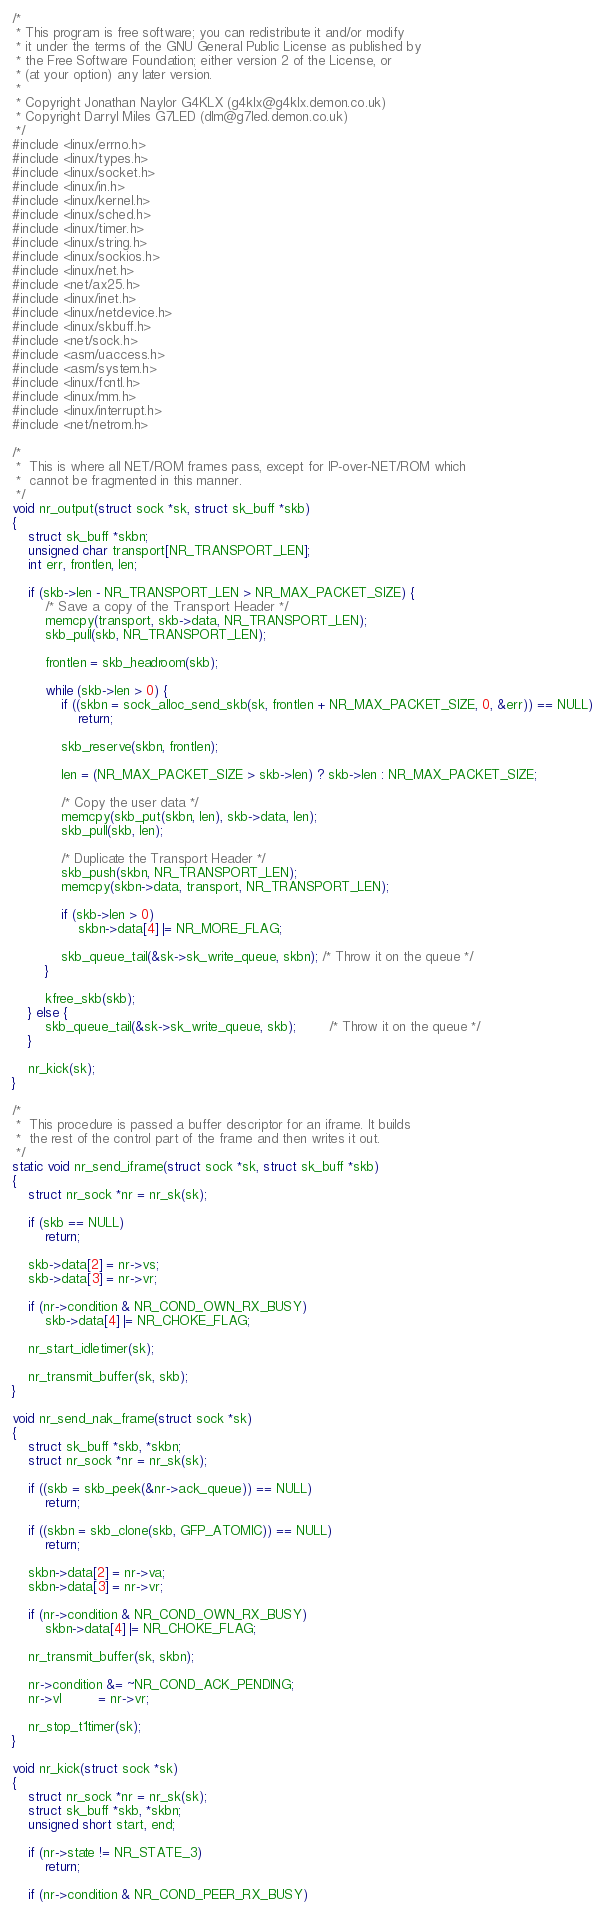Convert code to text. <code><loc_0><loc_0><loc_500><loc_500><_C_>/*
 * This program is free software; you can redistribute it and/or modify
 * it under the terms of the GNU General Public License as published by
 * the Free Software Foundation; either version 2 of the License, or
 * (at your option) any later version.
 *
 * Copyright Jonathan Naylor G4KLX (g4klx@g4klx.demon.co.uk)
 * Copyright Darryl Miles G7LED (dlm@g7led.demon.co.uk)
 */
#include <linux/errno.h>
#include <linux/types.h>
#include <linux/socket.h>
#include <linux/in.h>
#include <linux/kernel.h>
#include <linux/sched.h>
#include <linux/timer.h>
#include <linux/string.h>
#include <linux/sockios.h>
#include <linux/net.h>
#include <net/ax25.h>
#include <linux/inet.h>
#include <linux/netdevice.h>
#include <linux/skbuff.h>
#include <net/sock.h>
#include <asm/uaccess.h>
#include <asm/system.h>
#include <linux/fcntl.h>
#include <linux/mm.h>
#include <linux/interrupt.h>
#include <net/netrom.h>

/*
 *	This is where all NET/ROM frames pass, except for IP-over-NET/ROM which
 *	cannot be fragmented in this manner.
 */
void nr_output(struct sock *sk, struct sk_buff *skb)
{
	struct sk_buff *skbn;
	unsigned char transport[NR_TRANSPORT_LEN];
	int err, frontlen, len;

	if (skb->len - NR_TRANSPORT_LEN > NR_MAX_PACKET_SIZE) {
		/* Save a copy of the Transport Header */
		memcpy(transport, skb->data, NR_TRANSPORT_LEN);
		skb_pull(skb, NR_TRANSPORT_LEN);

		frontlen = skb_headroom(skb);

		while (skb->len > 0) {
			if ((skbn = sock_alloc_send_skb(sk, frontlen + NR_MAX_PACKET_SIZE, 0, &err)) == NULL)
				return;

			skb_reserve(skbn, frontlen);

			len = (NR_MAX_PACKET_SIZE > skb->len) ? skb->len : NR_MAX_PACKET_SIZE;

			/* Copy the user data */
			memcpy(skb_put(skbn, len), skb->data, len);
			skb_pull(skb, len);

			/* Duplicate the Transport Header */
			skb_push(skbn, NR_TRANSPORT_LEN);
			memcpy(skbn->data, transport, NR_TRANSPORT_LEN);

			if (skb->len > 0)
				skbn->data[4] |= NR_MORE_FLAG;

			skb_queue_tail(&sk->sk_write_queue, skbn); /* Throw it on the queue */
		}

		kfree_skb(skb);
	} else {
		skb_queue_tail(&sk->sk_write_queue, skb);		/* Throw it on the queue */
	}

	nr_kick(sk);
}

/*
 *	This procedure is passed a buffer descriptor for an iframe. It builds
 *	the rest of the control part of the frame and then writes it out.
 */
static void nr_send_iframe(struct sock *sk, struct sk_buff *skb)
{
	struct nr_sock *nr = nr_sk(sk);

	if (skb == NULL)
		return;

	skb->data[2] = nr->vs;
	skb->data[3] = nr->vr;

	if (nr->condition & NR_COND_OWN_RX_BUSY)
		skb->data[4] |= NR_CHOKE_FLAG;

	nr_start_idletimer(sk);

	nr_transmit_buffer(sk, skb);
}

void nr_send_nak_frame(struct sock *sk)
{
	struct sk_buff *skb, *skbn;
	struct nr_sock *nr = nr_sk(sk);

	if ((skb = skb_peek(&nr->ack_queue)) == NULL)
		return;

	if ((skbn = skb_clone(skb, GFP_ATOMIC)) == NULL)
		return;

	skbn->data[2] = nr->va;
	skbn->data[3] = nr->vr;

	if (nr->condition & NR_COND_OWN_RX_BUSY)
		skbn->data[4] |= NR_CHOKE_FLAG;

	nr_transmit_buffer(sk, skbn);

	nr->condition &= ~NR_COND_ACK_PENDING;
	nr->vl         = nr->vr;

	nr_stop_t1timer(sk);
}

void nr_kick(struct sock *sk)
{
	struct nr_sock *nr = nr_sk(sk);
	struct sk_buff *skb, *skbn;
	unsigned short start, end;

	if (nr->state != NR_STATE_3)
		return;

	if (nr->condition & NR_COND_PEER_RX_BUSY)</code> 